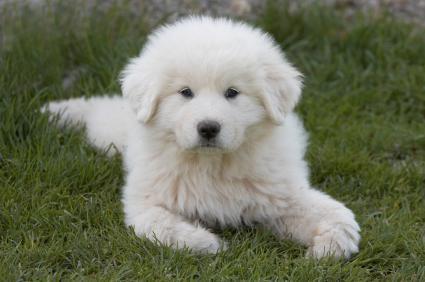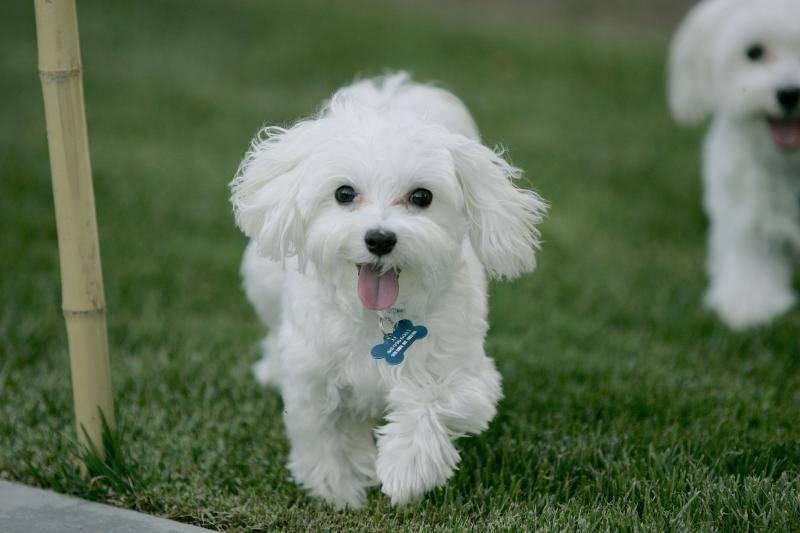The first image is the image on the left, the second image is the image on the right. Considering the images on both sides, is "One of the dogs is sitting with its legs extended on the ground." valid? Answer yes or no. Yes. 